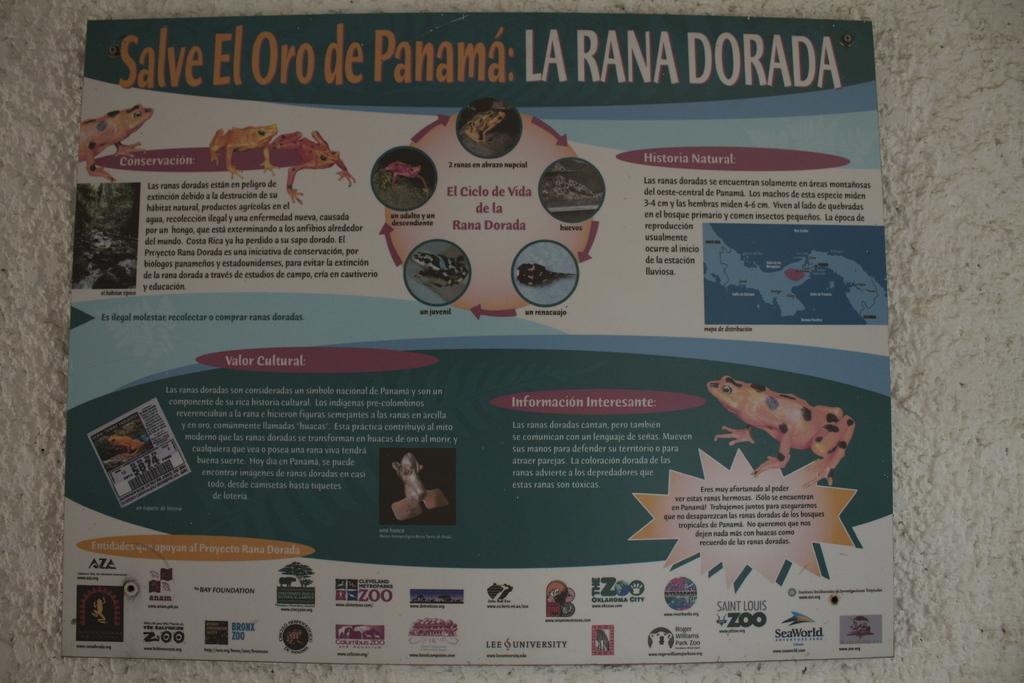Is this written in spanish?
Your answer should be compact. Yes. What does the top words say?
Give a very brief answer. Salve el oro de panama: la rana dorada. 